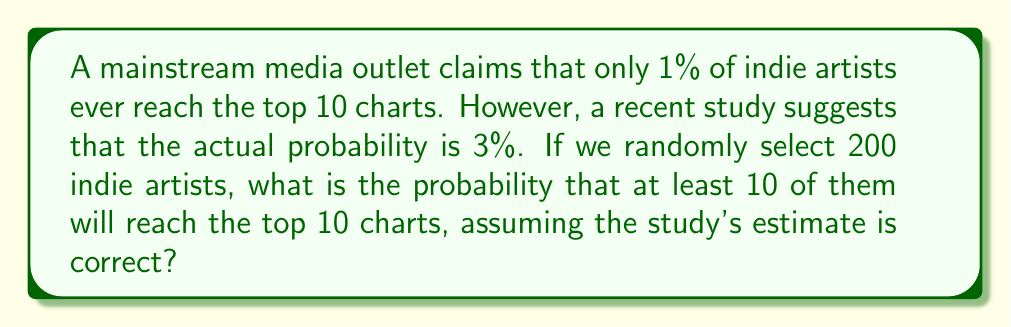Provide a solution to this math problem. To solve this problem, we can use the binomial distribution. Let's break it down step-by-step:

1) Let X be the number of indie artists who reach the top 10 charts out of 200 selected.

2) X follows a binomial distribution with n = 200 (number of trials) and p = 0.03 (probability of success).

3) We want to find P(X ≥ 10).

4) This is equivalent to 1 - P(X < 10) = 1 - P(X ≤ 9).

5) We can use the cumulative binomial probability function:

   $$P(X \leq k) = \sum_{i=0}^k \binom{n}{i} p^i (1-p)^{n-i}$$

6) In this case:
   $$P(X \geq 10) = 1 - P(X \leq 9) = 1 - \sum_{i=0}^9 \binom{200}{i} (0.03)^i (0.97)^{200-i}$$

7) This calculation is complex to do by hand, so we would typically use statistical software or a calculator with binomial probability functions.

8) Using such a tool, we find:

   $$P(X \geq 10) \approx 0.8752$$

This means there's about an 87.52% chance that at least 10 out of 200 randomly selected indie artists will reach the top 10 charts, assuming the study's 3% estimate is correct.
Answer: $P(X \geq 10) \approx 0.8752$ or approximately 87.52% 